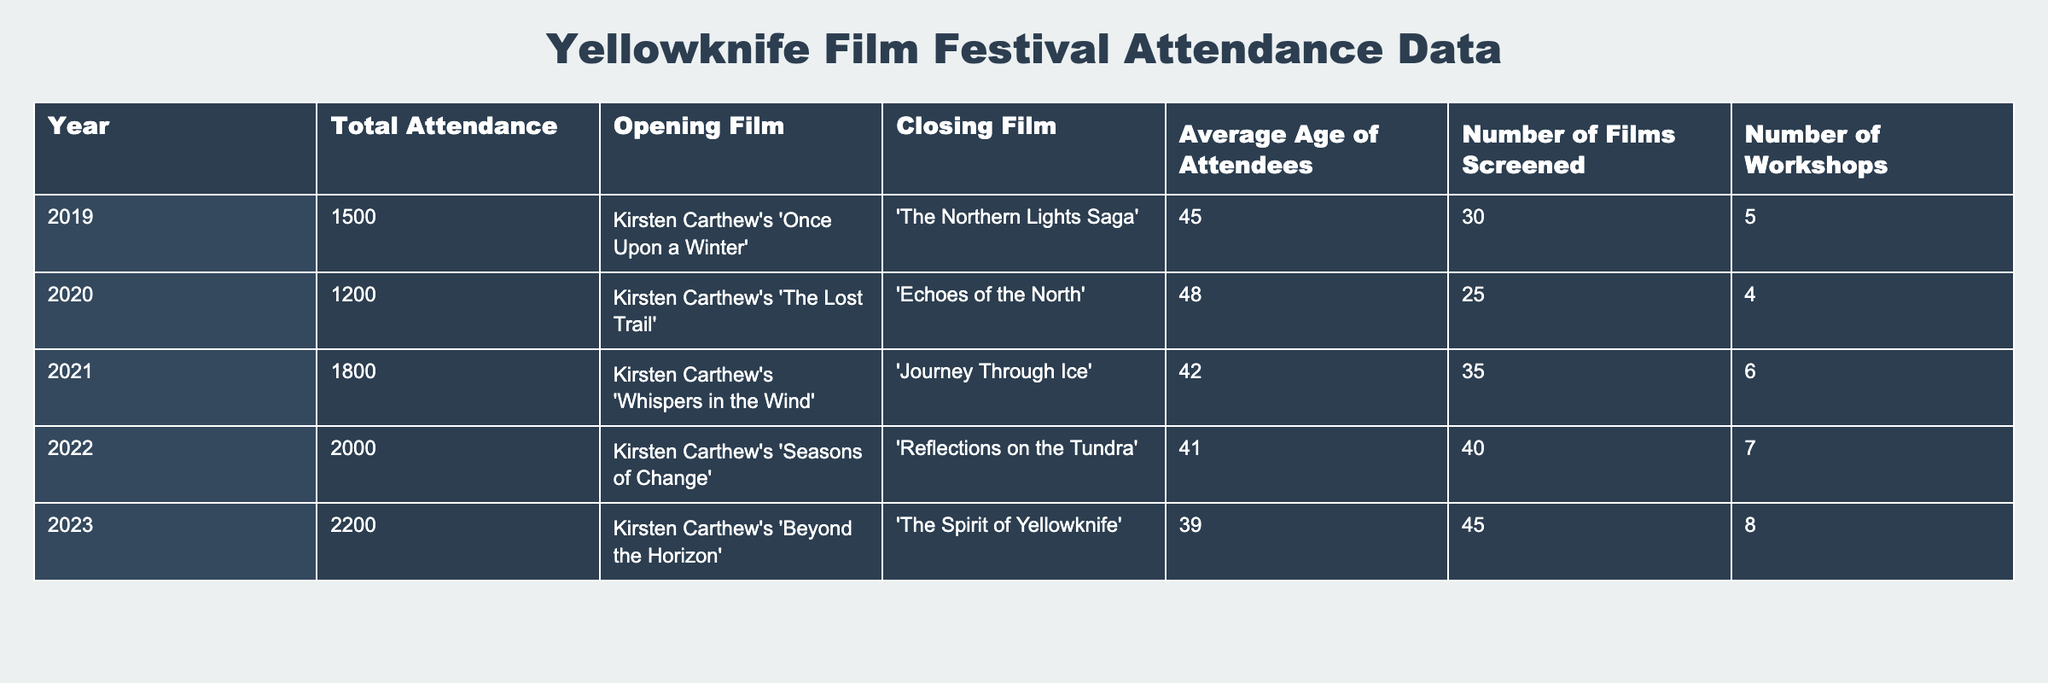What was the total attendance in 2021? Referring to the table, the total attendance listed for the year 2021 is 1800.
Answer: 1800 What was the average age of attendees in 2020? According to the table, the average age of attendees in 2020 is 48.
Answer: 48 Which film opened the festival in 2022? The table indicates that the opening film in 2022 was "Kirsten Carthew's 'Seasons of Change'."
Answer: "Kirsten Carthew's 'Seasons of Change'" How many workshops were held in 2023? The table shows that there were 8 workshops in 2023.
Answer: 8 What is the difference in total attendance between 2019 and 2023? The total attendance in 2019 was 1500, while in 2023 it was 2200. The difference is 2200 - 1500 = 700.
Answer: 700 What was the average attendance over the five years? The total attendance over the five years is (1500 + 1200 + 1800 + 2000 + 2200) = 10800. Since there are 5 years, the average attendance is 10800 / 5 = 2160.
Answer: 2160 Did the number of films screened increase every year from 2019 to 2023? By examining the table, we can see the number of films screened went from 30 in 2019 to 45 in 2023, and it increased each year: 30 → 25 → 35 → 40 → 45. Thus, the statement is true.
Answer: Yes What was the trend in average age of attendees from 2019 to 2023? The average age of attendees decreased from 45 in 2019 to 39 in 2023, showing a downward trend over the five years.
Answer: Downward trend What was the highest number of films screened in a single year? The table indicates that the highest number of films screened was 45 in 2023.
Answer: 45 How many more films were screened in 2022 compared to 2020? In 2022, 40 films were screened, and in 2020, 25 films were screened. The difference is 40 - 25 = 15.
Answer: 15 